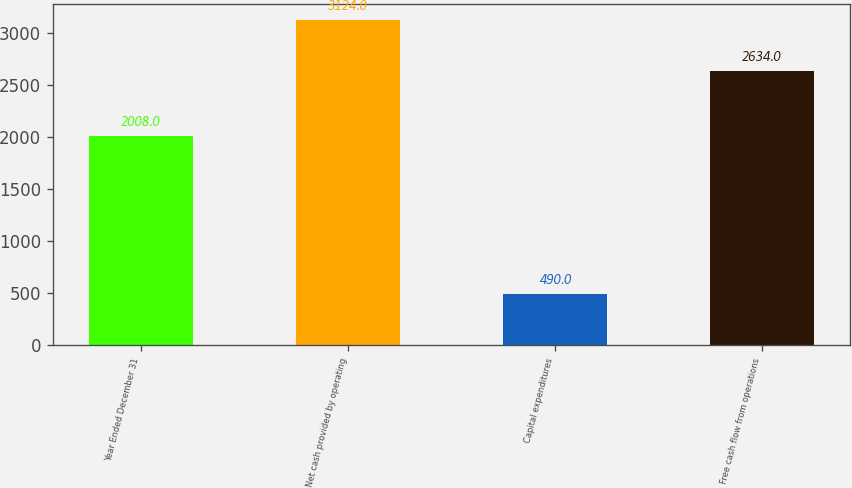Convert chart to OTSL. <chart><loc_0><loc_0><loc_500><loc_500><bar_chart><fcel>Year Ended December 31<fcel>Net cash provided by operating<fcel>Capital expenditures<fcel>Free cash flow from operations<nl><fcel>2008<fcel>3124<fcel>490<fcel>2634<nl></chart> 